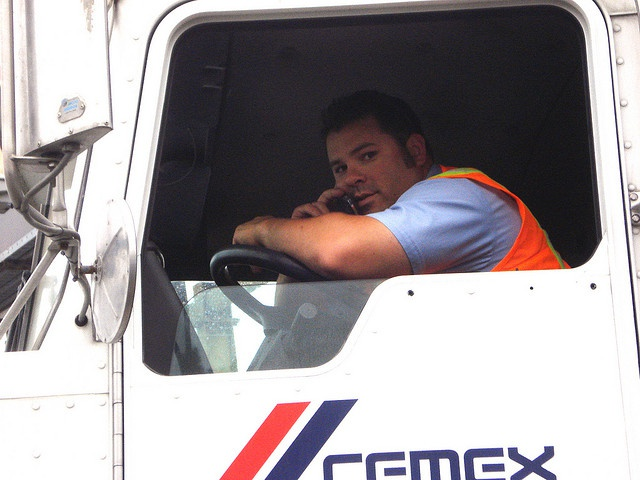Describe the objects in this image and their specific colors. I can see truck in white, black, gray, and darkgray tones, people in white, black, maroon, gray, and brown tones, and cell phone in white, black, maroon, and gray tones in this image. 